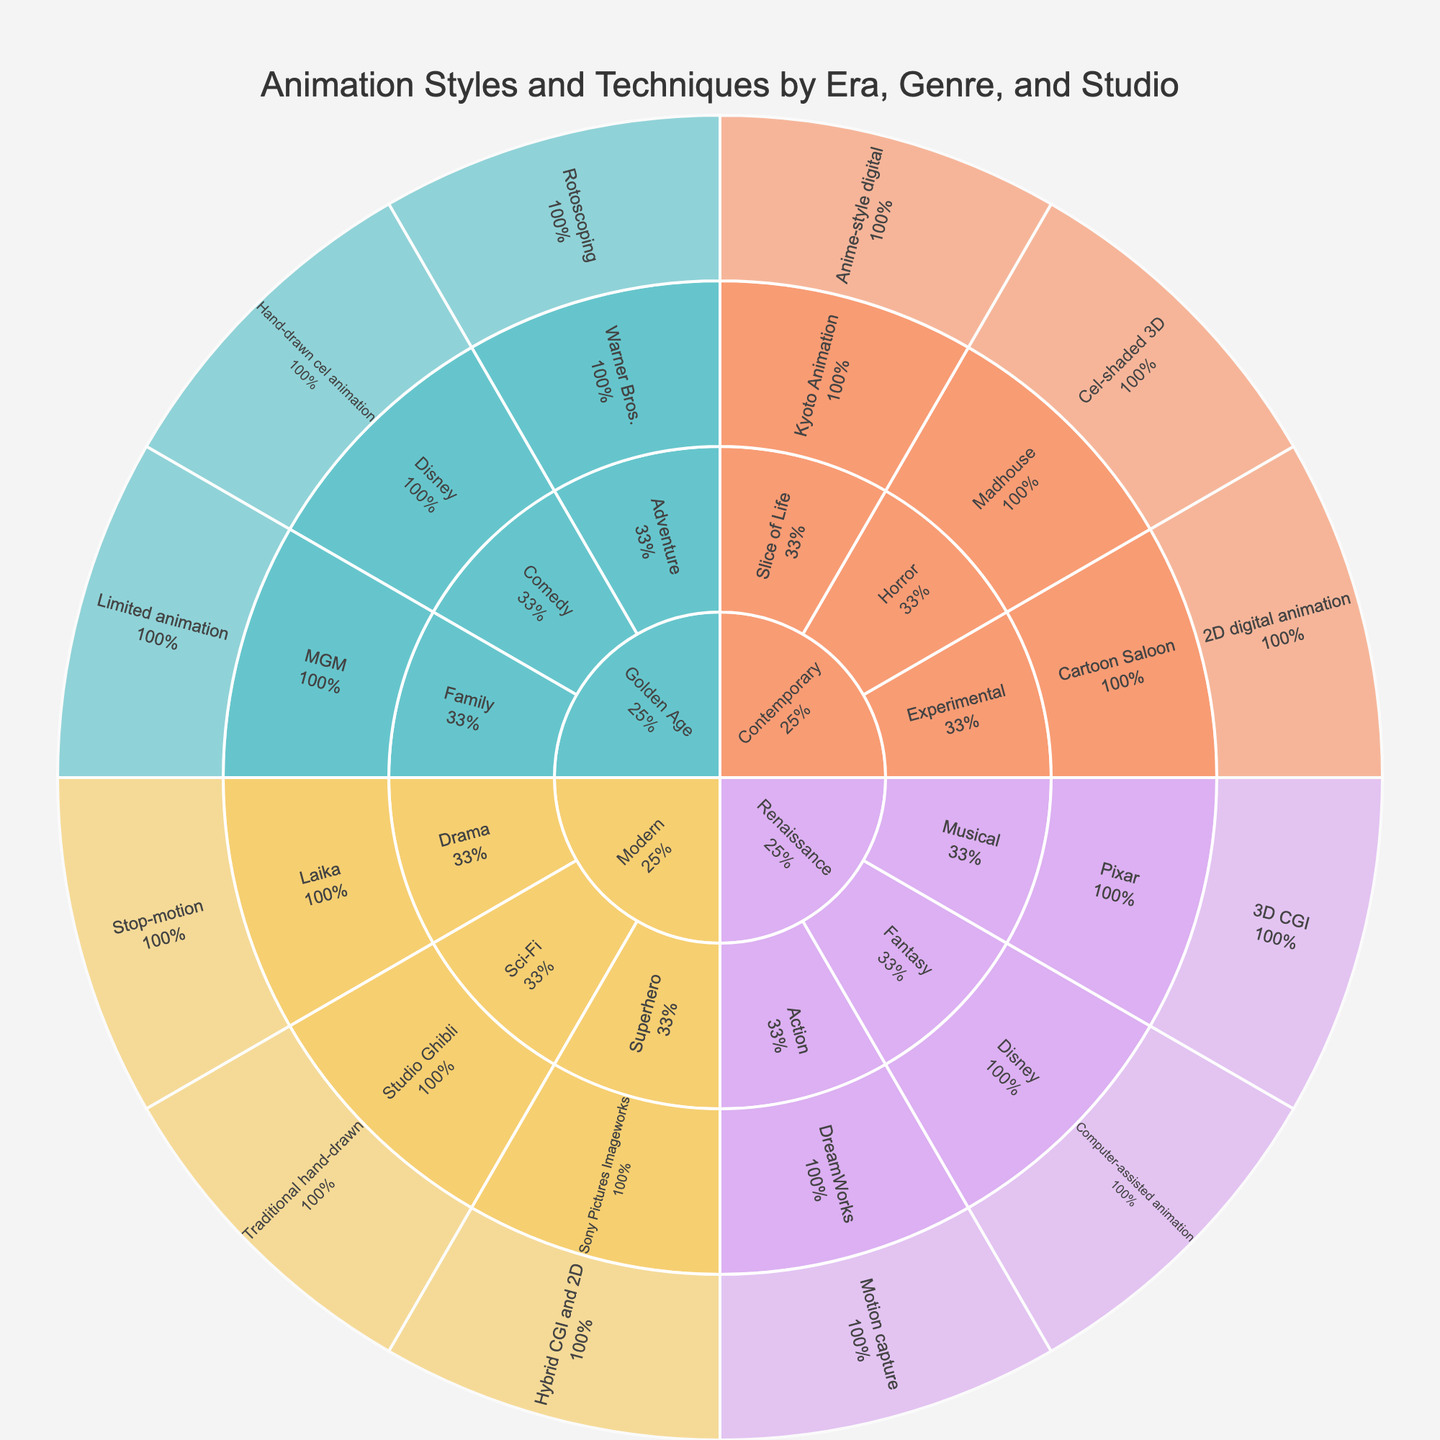What's the main title of the figure? The title is often presented prominently in the figure, usually at the top. It gives a quick summary of what the visualization is about.
Answer: Animation Styles and Techniques by Era, Genre, and Studio Which era has the genre "Horror" represented in the figure? To find the era that includes the genre "Horror," you look for the section labeled "Horror" and trace it back to its parent section, which would be the era.
Answer: Contemporary What percentage of "Modern" era animations are in the "Superhero" genre? To find this percentage, locate the "Superhero" genre within the "Modern" era section and read off the percentage that it represents within its parent section.
Answer: 33.3% How many studios used the "Computer-assisted animation" technique in the "Renaissance" era? Find the section corresponding to the "Renaissance" era, then look for the instances of "Computer-assisted animation" and count the number of studios listed under it.
Answer: 1 (Disney) Compare the "Golden Age" with the "Renaissance" era: Which has more genres represented? Count the number of unique genres within each era section by observing the different labels under "Golden Age" and "Renaissance" and compare these counts.
Answer: Golden Age Which studio utilized "Hand-drawn cel animation" during the "Golden Age" era? Locate the "Golden Age" era and then the "Hand-drawn cel animation" technique under it. Follow the path to find the studio associated with this technique.
Answer: Disney Identify the studio associated with "Stop-motion" animation in the "Modern" era Look in the "Modern" era section and locate "Stop-motion" animation, then follow the path to find the associated studio.
Answer: Laika Between the "Golden Age" and "Contemporary" era, which one has a greater variety of animation techniques? Compare the number of distinct animation techniques listed under the "Golden Age" and "Contemporary" eras to determine which has a greater variety.
Answer: Contemporary What percentage of animations in the "Contemporary" era are categorized as "Slice of Life"? Locate the "Slice of Life" category within the "Contemporary" era and read the percentage indicated for that section.
Answer: 33.3% Which era has the most diverse use of studios in its data representation? Look for the era with the highest number of unique studio labels under it to find which one has the most diverse use of studios.
Answer: Contemporary 